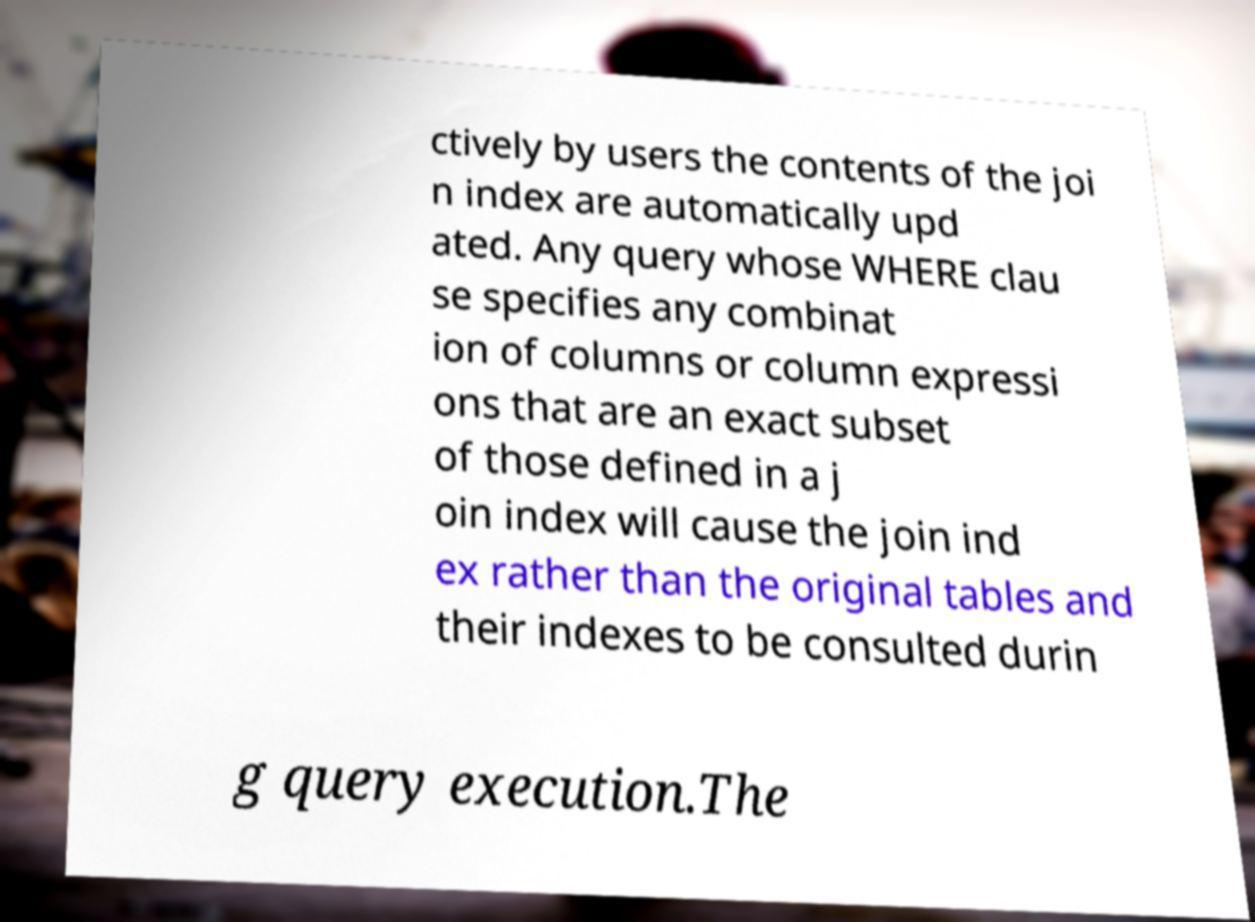Can you accurately transcribe the text from the provided image for me? ctively by users the contents of the joi n index are automatically upd ated. Any query whose WHERE clau se specifies any combinat ion of columns or column expressi ons that are an exact subset of those defined in a j oin index will cause the join ind ex rather than the original tables and their indexes to be consulted durin g query execution.The 